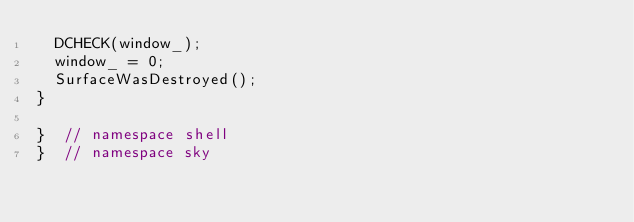Convert code to text. <code><loc_0><loc_0><loc_500><loc_500><_ObjectiveC_>  DCHECK(window_);
  window_ = 0;
  SurfaceWasDestroyed();
}

}  // namespace shell
}  // namespace sky
</code> 